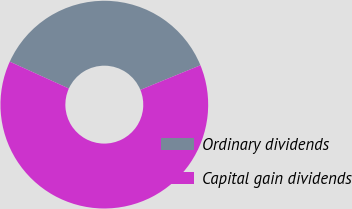Convert chart to OTSL. <chart><loc_0><loc_0><loc_500><loc_500><pie_chart><fcel>Ordinary dividends<fcel>Capital gain dividends<nl><fcel>37.02%<fcel>62.98%<nl></chart> 